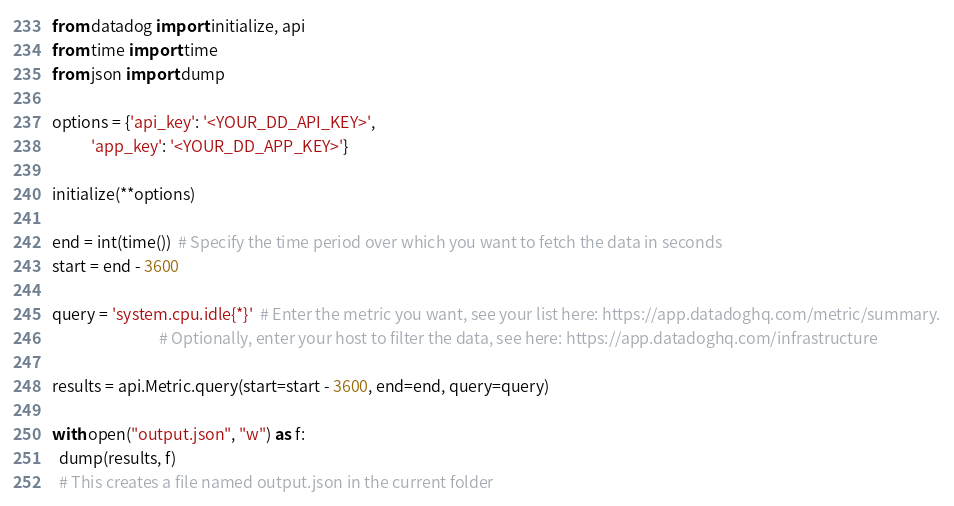Convert code to text. <code><loc_0><loc_0><loc_500><loc_500><_Python_>from datadog import initialize, api
from time import time
from json import dump

options = {'api_key': '<YOUR_DD_API_KEY>',
           'app_key': '<YOUR_DD_APP_KEY>'}

initialize(**options)

end = int(time())  # Specify the time period over which you want to fetch the data in seconds
start = end - 3600

query = 'system.cpu.idle{*}'  # Enter the metric you want, see your list here: https://app.datadoghq.com/metric/summary.
                              # Optionally, enter your host to filter the data, see here: https://app.datadoghq.com/infrastructure

results = api.Metric.query(start=start - 3600, end=end, query=query)

with open("output.json", "w") as f:
  dump(results, f)
  # This creates a file named output.json in the current folder
</code> 